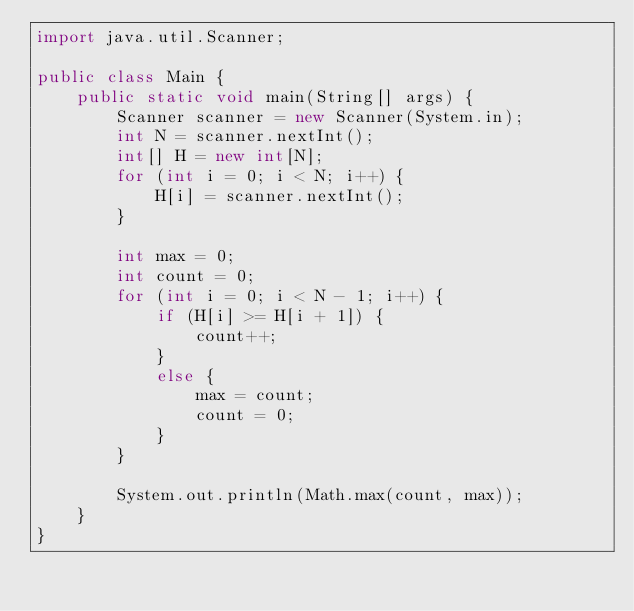Convert code to text. <code><loc_0><loc_0><loc_500><loc_500><_Java_>import java.util.Scanner;

public class Main {
	public static void main(String[] args) {
		Scanner scanner = new Scanner(System.in);
		int N = scanner.nextInt();
		int[] H = new int[N];
		for (int i = 0; i < N; i++) {
			H[i] = scanner.nextInt();
		}

		int max = 0;
		int count = 0;
		for (int i = 0; i < N - 1; i++) {
			if (H[i] >= H[i + 1]) {
				count++;
			}
			else {
				max = count;
				count = 0;
			}
		}

		System.out.println(Math.max(count, max));
	}
}</code> 